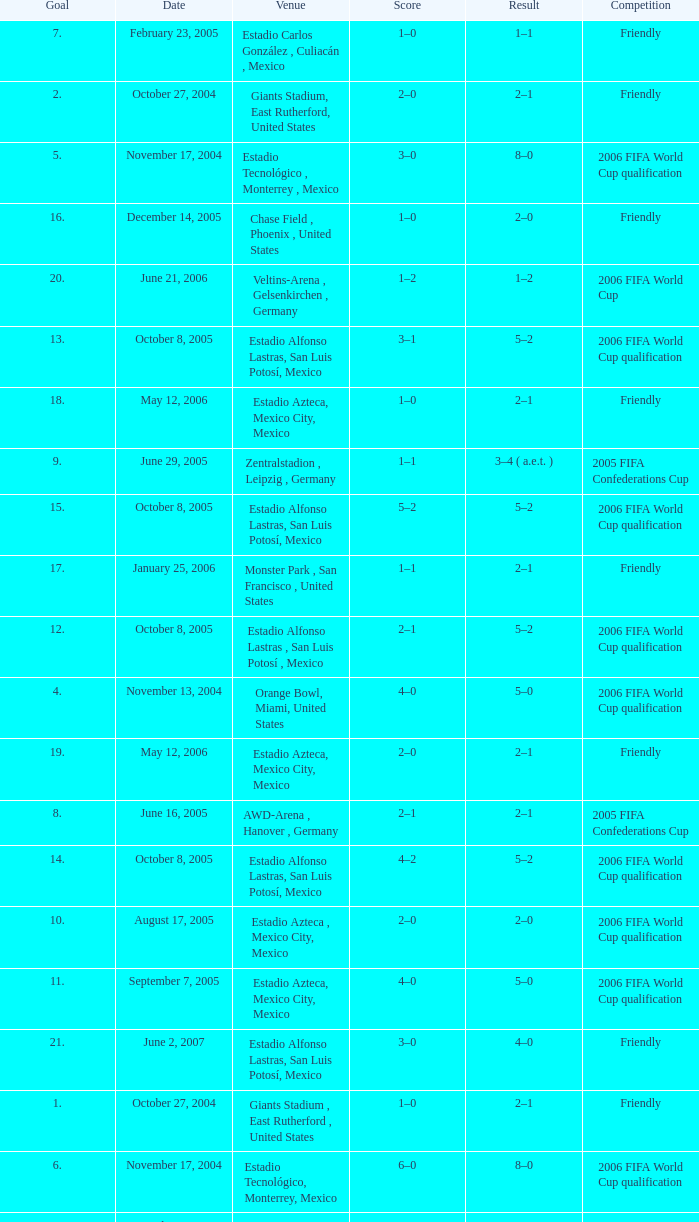Which Score has a Date of october 8, 2005, and a Venue of estadio alfonso lastras, san luis potosí, mexico? 2–1, 3–1, 4–2, 5–2. 